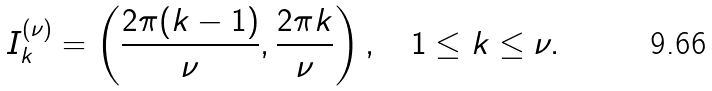<formula> <loc_0><loc_0><loc_500><loc_500>I ^ { ( \nu ) } _ { k } = \left ( \frac { 2 \pi ( k - 1 ) } { \nu } , \frac { 2 \pi k } { \nu } \right ) , \quad 1 \leq k \leq \nu .</formula> 